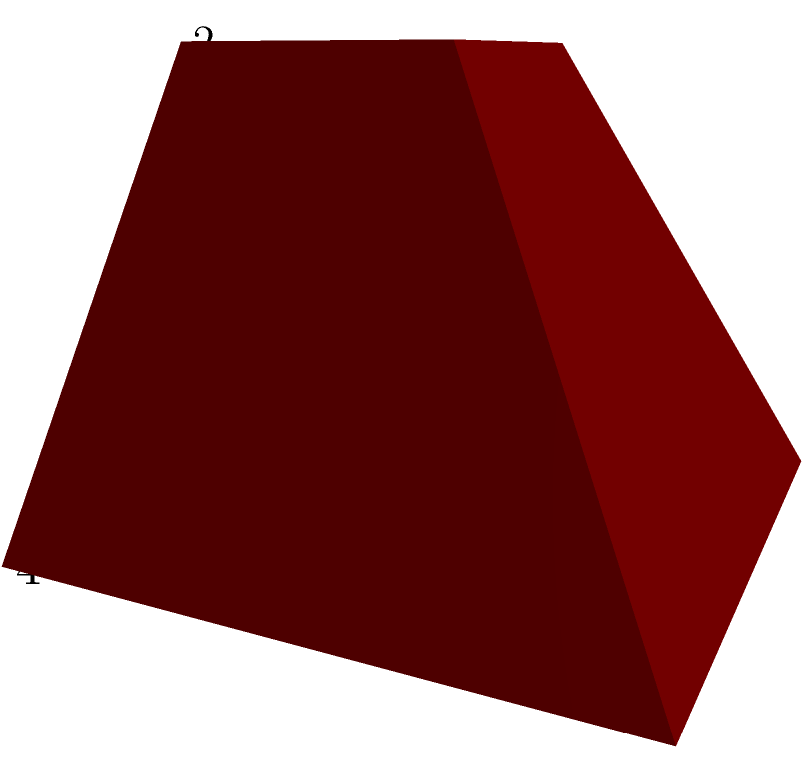A truncated pyramid, reminiscent of Mesoamerican step pyramids, has a square base with side length 4 units, a square top with side length 2 units, and a height of 3 units. Calculate the volume of this truncated pyramid, considering its similarity to architectural structures found in Indigenous Mesoamerican cultures. To calculate the volume of a truncated pyramid, we can use the formula:

$$V = \frac{1}{3}h(a^2 + ab + b^2)$$

Where:
$V$ = volume
$h$ = height of the truncated pyramid
$a$ = side length of the base
$b$ = side length of the top

Given:
$h = 3$ units
$a = 4$ units
$b = 2$ units

Let's substitute these values into the formula:

$$V = \frac{1}{3} \cdot 3(4^2 + 4 \cdot 2 + 2^2)$$

Now, let's solve step by step:

1) First, calculate the terms inside the parentheses:
   $4^2 = 16$
   $4 \cdot 2 = 8$
   $2^2 = 4$

2) Add these terms:
   $16 + 8 + 4 = 28$

3) Multiply by the height and $\frac{1}{3}$:
   $$V = \frac{1}{3} \cdot 3 \cdot 28 = 28$$

Therefore, the volume of the truncated pyramid is 28 cubic units.

This calculation method, while mathematical, reflects the advanced architectural knowledge of Indigenous Mesoamerican cultures, who constructed complex stepped pyramids with precise measurements and proportions.
Answer: 28 cubic units 